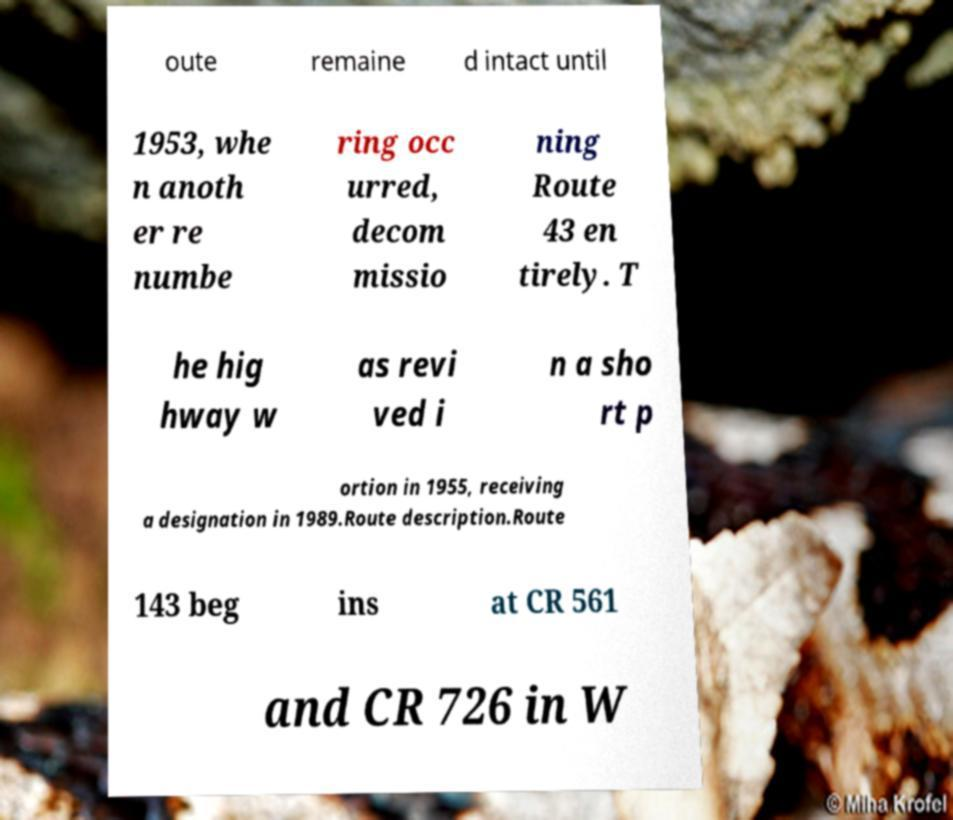Can you read and provide the text displayed in the image?This photo seems to have some interesting text. Can you extract and type it out for me? oute remaine d intact until 1953, whe n anoth er re numbe ring occ urred, decom missio ning Route 43 en tirely. T he hig hway w as revi ved i n a sho rt p ortion in 1955, receiving a designation in 1989.Route description.Route 143 beg ins at CR 561 and CR 726 in W 